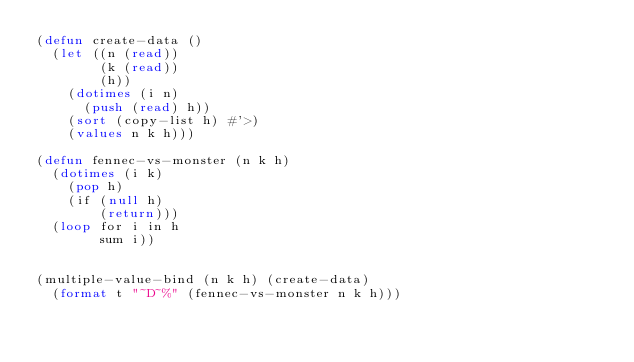Convert code to text. <code><loc_0><loc_0><loc_500><loc_500><_Lisp_>(defun create-data ()
  (let ((n (read))
        (k (read))
        (h))
    (dotimes (i n)
      (push (read) h))
    (sort (copy-list h) #'>)
    (values n k h)))

(defun fennec-vs-monster (n k h)
  (dotimes (i k) 
    (pop h) 
    (if (null h) 
        (return))) 
  (loop for i in h 
        sum i)) 


(multiple-value-bind (n k h) (create-data)
  (format t "~D~%" (fennec-vs-monster n k h)))

</code> 